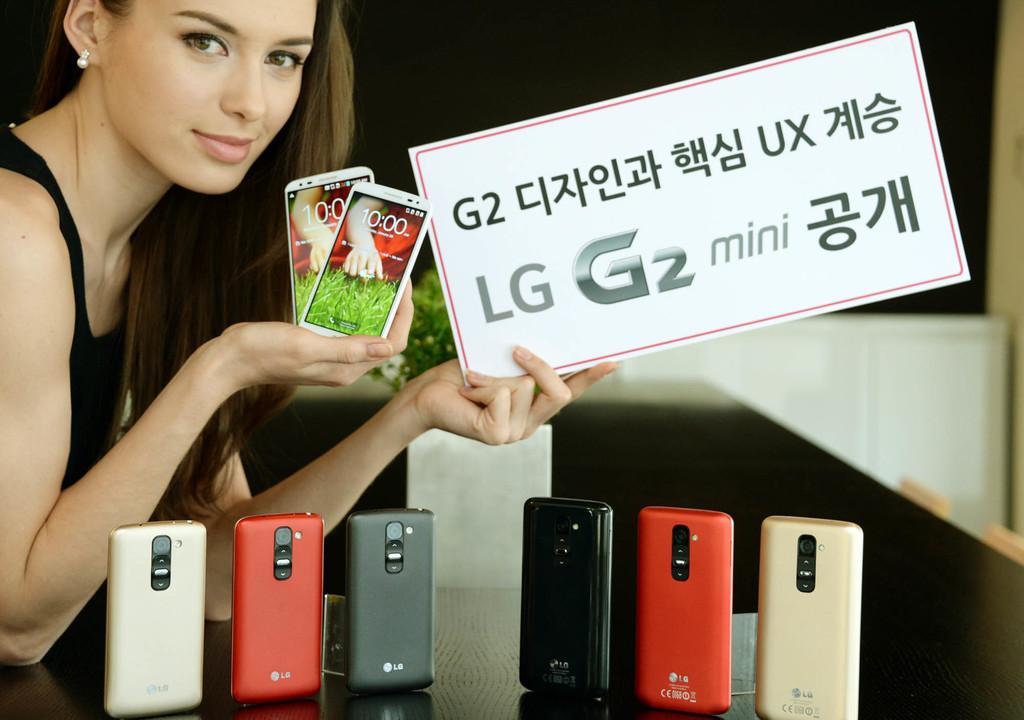What brand are those phones?
Keep it short and to the point. Lg. Are these phones full size?
Offer a very short reply. No. 